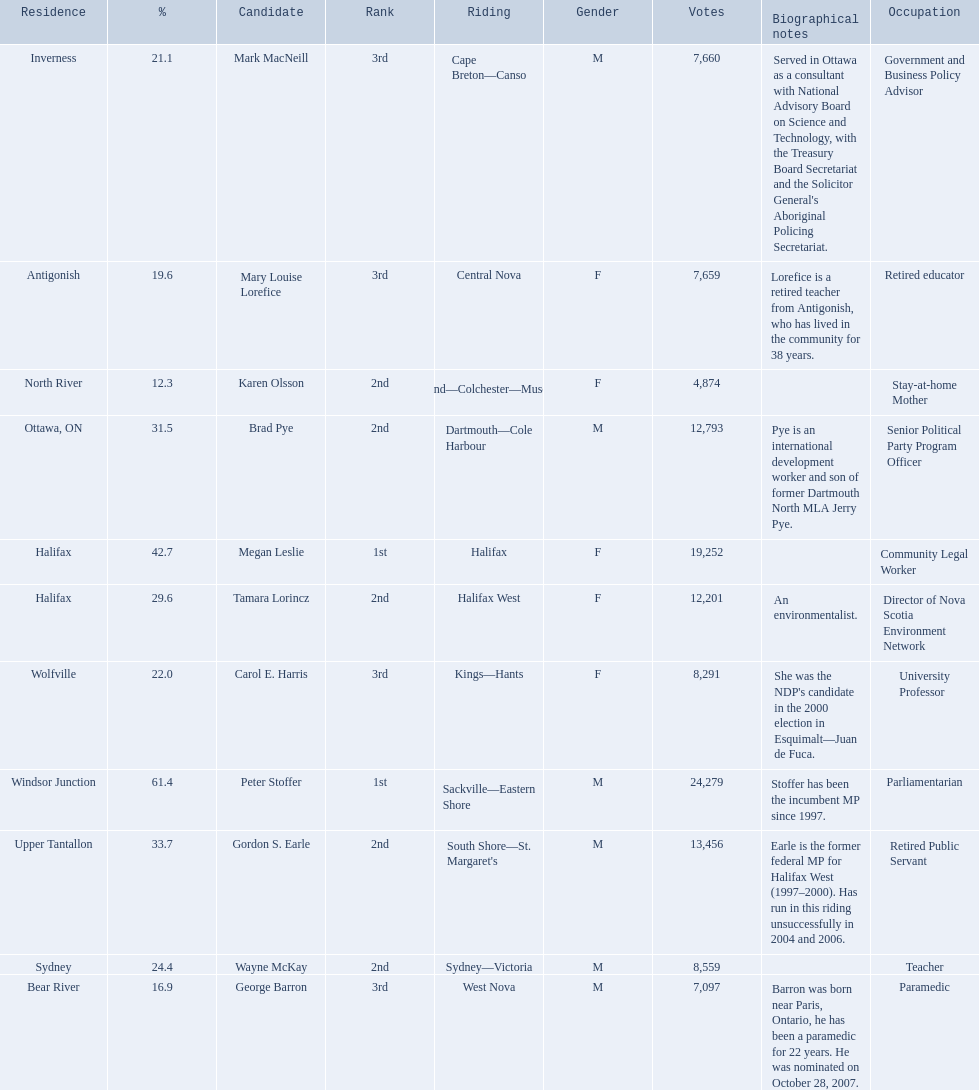Which candidates have the four lowest amount of votes Mark MacNeill, Mary Louise Lorefice, Karen Olsson, George Barron. Out of the following, who has the third most? Mark MacNeill. 